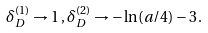<formula> <loc_0><loc_0><loc_500><loc_500>\delta ^ { ( 1 ) } _ { D } \rightarrow 1 \, , \delta ^ { ( 2 ) } _ { D } \rightarrow - \ln ( a / 4 ) - 3 \, .</formula> 